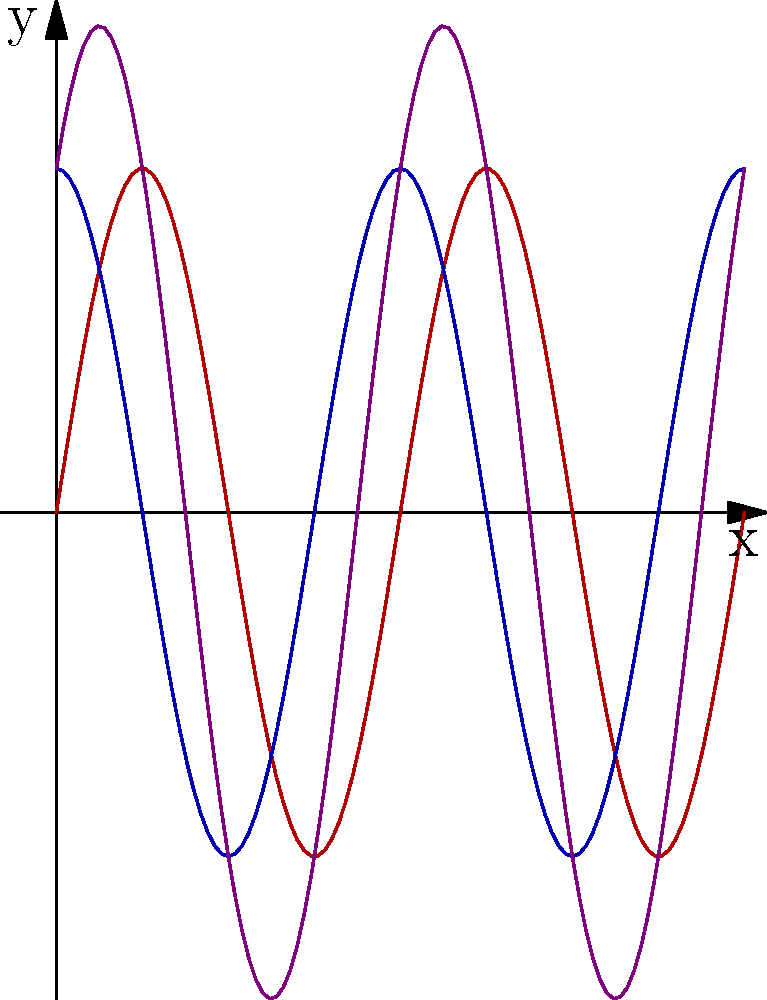In this visual representation of wave interference, akin to the complex interplay of human emotions in a tragedy, we observe two sinusoidal waves and their resulting interference pattern. If the amplitude of each individual wave is $A$, what is the maximum amplitude of the interference pattern, and how does this relate to the crescendo of emotional intensity in a well-crafted dramatic work? To determine the maximum amplitude of the interference pattern, we must analyze the interaction between the two waves:

1. The two waves are represented by:
   Wave 1: $y_1 = A \sin(2\pi x)$
   Wave 2: $y_2 = A \sin(2\pi x + \frac{\pi}{2})$

2. The phase difference between the waves is $\frac{\pi}{2}$, or a quarter-wavelength.

3. The resulting interference pattern is the sum of these waves:
   $y = y_1 + y_2 = A \sin(2\pi x) + A \sin(2\pi x + \frac{\pi}{2})$

4. Using the trigonometric identity for the sum of sines:
   $\sin A + \sin B = 2 \sin(\frac{A+B}{2}) \cos(\frac{A-B}{2})$

5. Applying this to our equation:
   $y = 2A \sin(2\pi x + \frac{\pi}{4}) \cos(\frac{\pi}{4})$

6. The amplitude of this new wave is:
   $2A \cos(\frac{\pi}{4}) = 2A \cdot \frac{\sqrt{2}}{2} = A\sqrt{2}$

7. Therefore, the maximum amplitude of the interference pattern is $A\sqrt{2}$.

This amplification of the original waves' amplitude parallels the way a skilled playwright intensifies emotions in a drama. Just as the interference pattern reaches heights greater than either individual wave, a well-crafted tragic scene can evoke a depth of feeling that surpasses the sum of its parts, creating a profound and lasting impact on the audience.
Answer: $A\sqrt{2}$ 